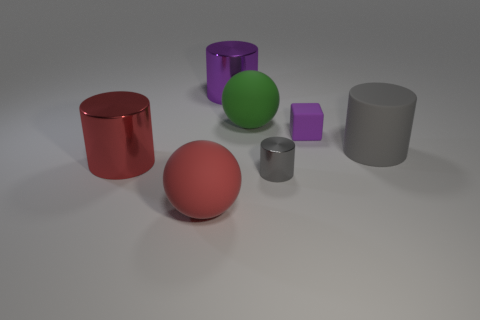There is a purple cube that is made of the same material as the big gray thing; what size is it?
Your answer should be very brief. Small. There is a green thing; is it the same shape as the big object that is in front of the small metallic object?
Provide a short and direct response. Yes. What is the size of the red matte sphere?
Provide a succinct answer. Large. Is the number of large objects that are left of the big red sphere less than the number of cylinders?
Your response must be concise. Yes. How many gray things have the same size as the red rubber object?
Offer a very short reply. 1. There is a large metal cylinder behind the gray matte cylinder; is its color the same as the tiny object behind the tiny gray metal object?
Offer a terse response. Yes. There is a tiny gray cylinder; how many big rubber balls are behind it?
Make the answer very short. 1. The other rubber cylinder that is the same color as the tiny cylinder is what size?
Offer a very short reply. Large. Are there any other small gray metallic things that have the same shape as the tiny shiny object?
Offer a very short reply. No. The matte cylinder that is the same size as the green ball is what color?
Offer a very short reply. Gray. 